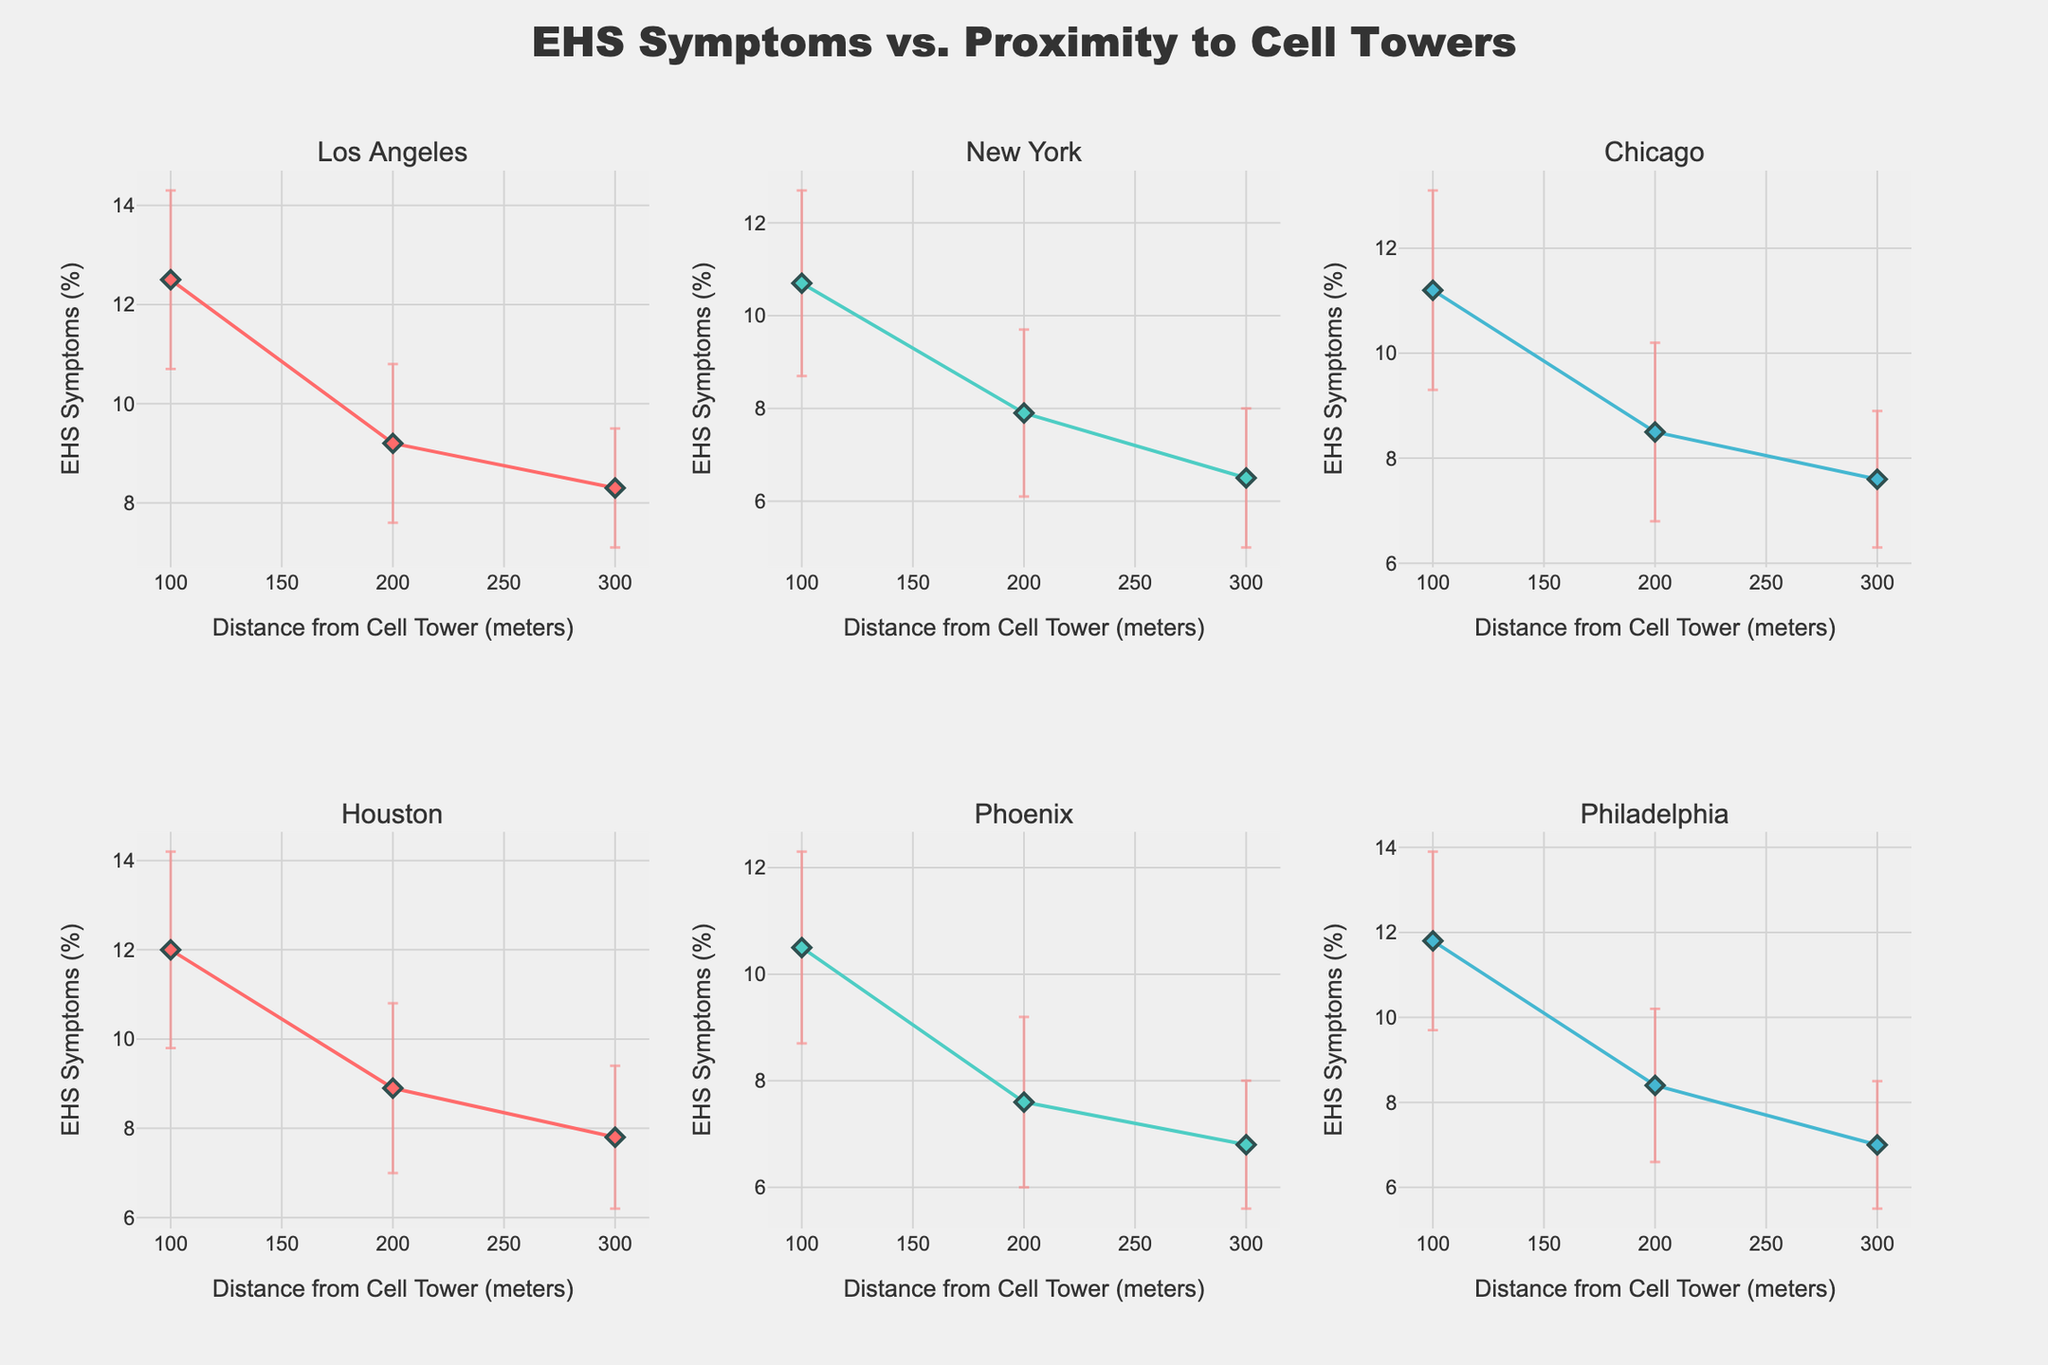What is the title of the plot? The title of the plot is displayed at the top of the figure, centered and in large font. It gives an overview of what is being depicted in the figure.
Answer: EHS Symptoms vs. Proximity to Cell Towers Which city shows the highest prevalence of EHS symptoms at 100 meters from the cell tower? By looking at the subplot for each city, compare the values for 100 meters to find which one is the highest.
Answer: Los Angeles How many subplots are there in the figure? Count the number of separate small charts within the larger figure; each subplot represents a different city.
Answer: 6 Which city shows the least prevalence of EHS symptoms at 300 meters from the cell tower? Examine the data points for 300 meters in each subplot to identify the lowest value.
Answer: New York What is the general trend in EHS symptoms prevalence as the distance from cell towers increases? Observe how the lines change from 100 to 300 meters in each subplot. The trend can be seen by how the y-values (EHS symptoms) change with increasing x-values (distance).
Answer: Decreases How does the standard error for EHS symptoms vary between cities? Look at the length of the error bars across different subplots to see if some cities have consistently larger or smaller error margins.
Answer: Varies, but generally similar At 200 meters from the cell tower, which city has the most substantial error margin for EHS symptoms? Compare the length of the error bars at 200 meters across all subplots to identify the city with the longest error bar.
Answer: Houston Is there a city where the prevalence of EHS symptoms is almost the same at 200 meters and 300 meters? Look for subplots where the data points for 200 and 300 meters are close together.
Answer: Philadelphia What's the difference in EHS symptom prevalence between 100 meters and 200 meters in Phoenix? Subtract the prevalence value at 200 meters from the value at 100 meters for the Phoenix subplot.
Answer: 2.9% Which city has the smallest decrease in EHS symptoms from 100 meters to 300 meters? Calculate the decrease in EHS symptoms from 100 meters to 300 meters for each city and find the smallest difference.
Answer: Phoenix 